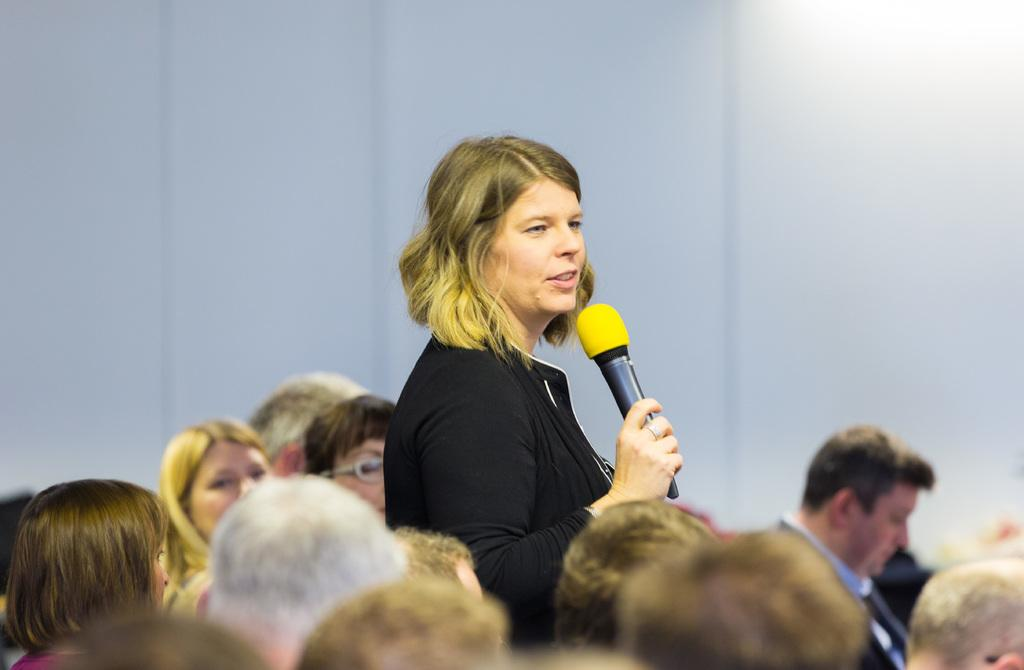Who is the main subject in the image? There is a woman in the image. What is the woman doing in the image? The woman is standing and talking into a microphone. What might be the context of the image? The image might be from a meeting, as there are people seated and the woman is speaking into a microphone. What is the color of the wall in the image? The wall in the image is painted white. What type of cherries are being served to the woman's brothers in the image? There are no cherries or brothers present in the image. 